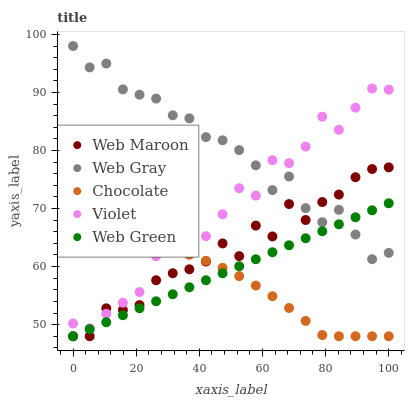Does Chocolate have the minimum area under the curve?
Answer yes or no. Yes. Does Web Gray have the maximum area under the curve?
Answer yes or no. Yes. Does Web Maroon have the minimum area under the curve?
Answer yes or no. No. Does Web Maroon have the maximum area under the curve?
Answer yes or no. No. Is Web Green the smoothest?
Answer yes or no. Yes. Is Web Maroon the roughest?
Answer yes or no. Yes. Is Web Gray the smoothest?
Answer yes or no. No. Is Web Gray the roughest?
Answer yes or no. No. Does Web Maroon have the lowest value?
Answer yes or no. Yes. Does Web Gray have the lowest value?
Answer yes or no. No. Does Web Gray have the highest value?
Answer yes or no. Yes. Does Web Maroon have the highest value?
Answer yes or no. No. Is Chocolate less than Web Gray?
Answer yes or no. Yes. Is Web Gray greater than Chocolate?
Answer yes or no. Yes. Does Chocolate intersect Violet?
Answer yes or no. Yes. Is Chocolate less than Violet?
Answer yes or no. No. Is Chocolate greater than Violet?
Answer yes or no. No. Does Chocolate intersect Web Gray?
Answer yes or no. No. 